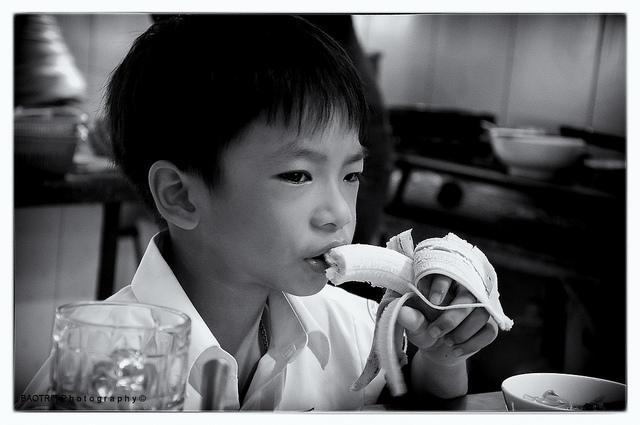How many bowls can you see?
Give a very brief answer. 3. How many people are there?
Give a very brief answer. 1. 